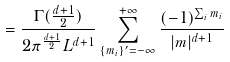Convert formula to latex. <formula><loc_0><loc_0><loc_500><loc_500>= \frac { \Gamma ( \frac { d + 1 } { 2 } ) } { 2 \pi ^ { \frac { d + 1 } { 2 } } L ^ { d + 1 } } \sum _ { \{ m _ { i } \} ^ { \prime } = - \infty } ^ { + \infty } \frac { ( - 1 ) ^ { \sum _ { i } m _ { i } } } { | { m } | ^ { d + 1 } }</formula> 